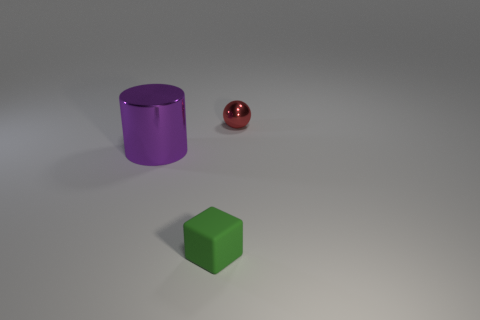Add 3 gray shiny spheres. How many objects exist? 6 Subtract all cylinders. How many objects are left? 2 Add 3 tiny objects. How many tiny objects exist? 5 Subtract 0 blue cubes. How many objects are left? 3 Subtract all purple metallic things. Subtract all large yellow rubber balls. How many objects are left? 2 Add 3 metal cylinders. How many metal cylinders are left? 4 